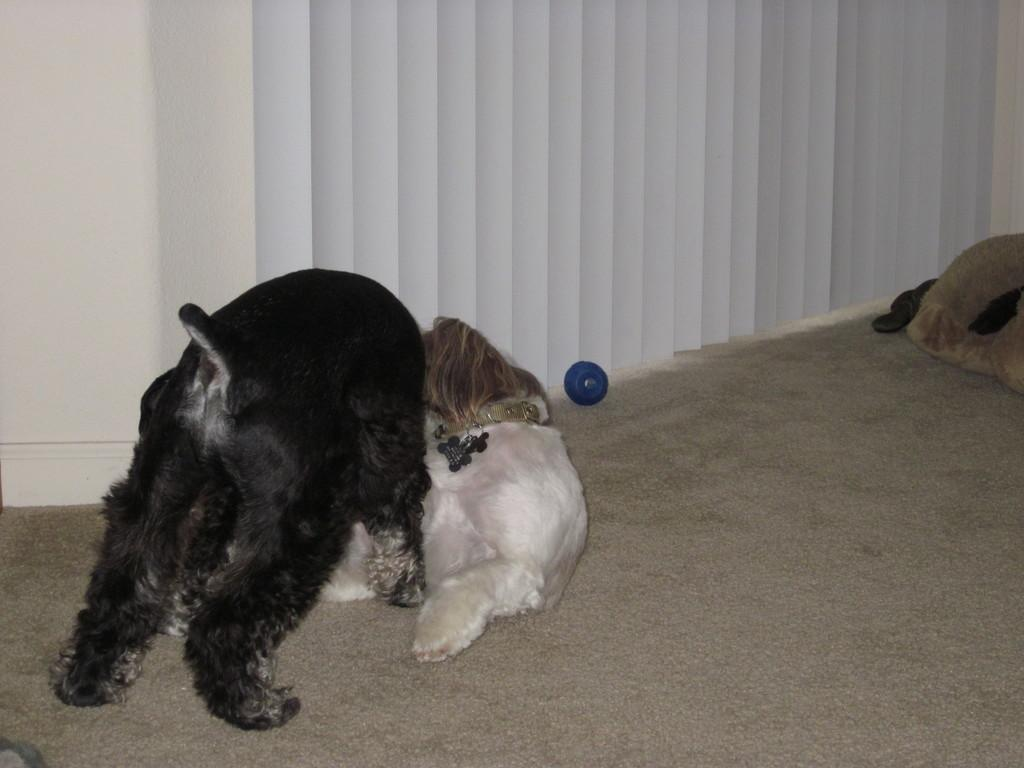What is on the floor in the image? There are animals on the floor in the image. Can you describe any unique features of the animals? One of the animals is wearing a belt. What color is the object visible in the image? There is a blue color object in the image. What can be seen in the background of the image? There is a wall and curtains visible in the background of the image. How does the animal's digestion process work in the image? There is no information about the animal's digestion process in the image. What is the slope of the floor in the image? There is no mention of a slope in the image; the floor appears to be flat. 